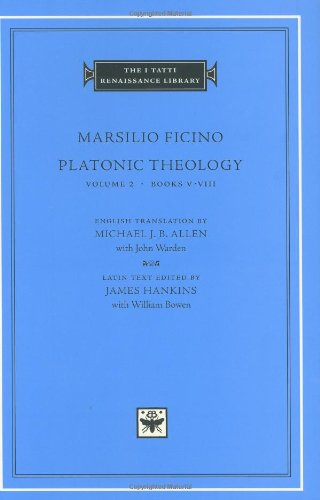What type of book is this? This book belongs to the genre of Philosophy, specifically dealing with Neo-Platonic thought, as it delves into the complexities of Platonic theology reflecting Marsilio Ficino's philosophical perspectives. 